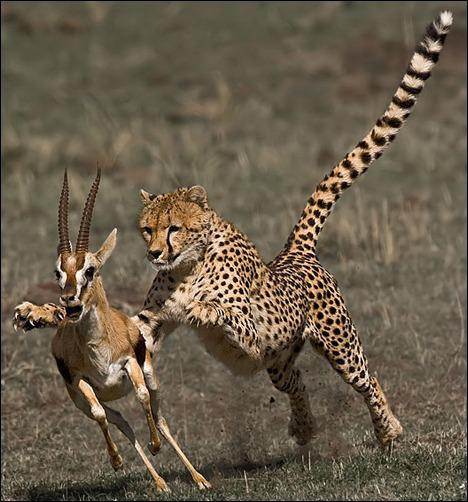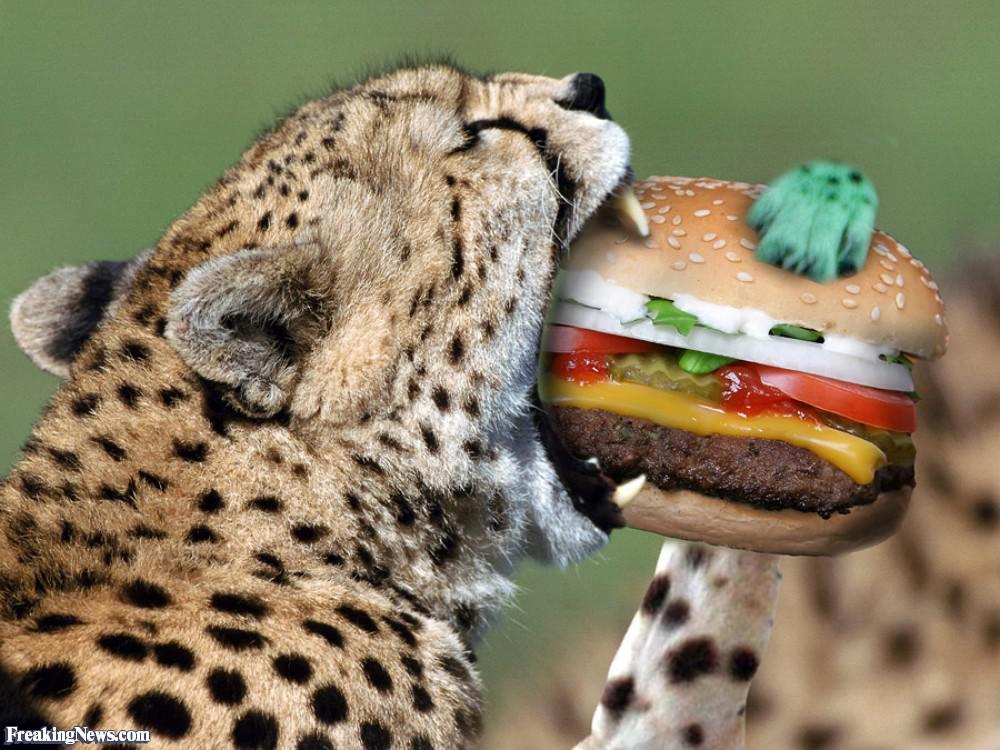The first image is the image on the left, the second image is the image on the right. Evaluate the accuracy of this statement regarding the images: "In at least one image there is a dead elk will all four if its legs in front of a cheetah.". Is it true? Answer yes or no. No. 